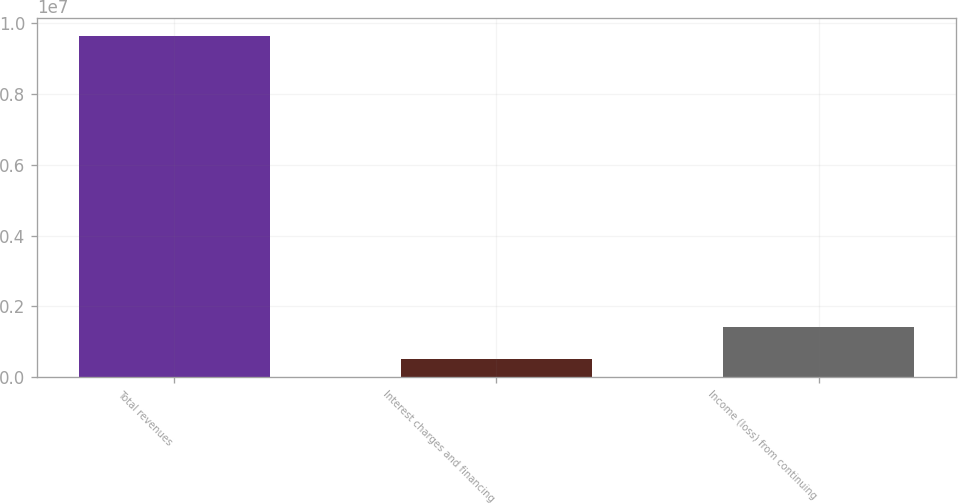<chart> <loc_0><loc_0><loc_500><loc_500><bar_chart><fcel>Total revenues<fcel>Interest charges and financing<fcel>Income (loss) from continuing<nl><fcel>9.6443e+06<fcel>521855<fcel>1.4341e+06<nl></chart> 